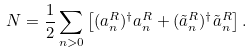Convert formula to latex. <formula><loc_0><loc_0><loc_500><loc_500>N = \frac { 1 } { 2 } \sum _ { n > 0 } \left [ ( a ^ { R } _ { n } ) ^ { \dagger } a ^ { R } _ { n } + ( \tilde { a } ^ { R } _ { n } ) ^ { \dagger } \tilde { a } ^ { R } _ { n } \right ] .</formula> 